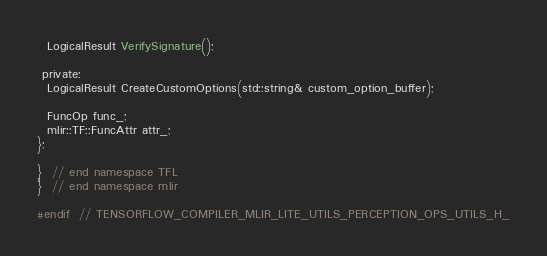Convert code to text. <code><loc_0><loc_0><loc_500><loc_500><_C_>
  LogicalResult VerifySignature();

 private:
  LogicalResult CreateCustomOptions(std::string& custom_option_buffer);

  FuncOp func_;
  mlir::TF::FuncAttr attr_;
};

}  // end namespace TFL
}  // end namespace mlir

#endif  // TENSORFLOW_COMPILER_MLIR_LITE_UTILS_PERCEPTION_OPS_UTILS_H_
</code> 